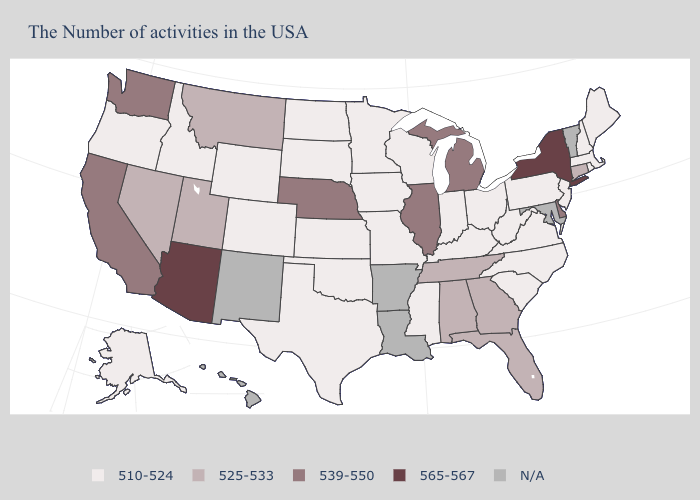What is the value of Louisiana?
Write a very short answer. N/A. Name the states that have a value in the range 539-550?
Keep it brief. Delaware, Michigan, Illinois, Nebraska, California, Washington. Name the states that have a value in the range 510-524?
Short answer required. Maine, Massachusetts, Rhode Island, New Hampshire, New Jersey, Pennsylvania, Virginia, North Carolina, South Carolina, West Virginia, Ohio, Kentucky, Indiana, Wisconsin, Mississippi, Missouri, Minnesota, Iowa, Kansas, Oklahoma, Texas, South Dakota, North Dakota, Wyoming, Colorado, Idaho, Oregon, Alaska. What is the lowest value in the MidWest?
Short answer required. 510-524. Is the legend a continuous bar?
Write a very short answer. No. How many symbols are there in the legend?
Answer briefly. 5. Does the map have missing data?
Concise answer only. Yes. Name the states that have a value in the range 510-524?
Keep it brief. Maine, Massachusetts, Rhode Island, New Hampshire, New Jersey, Pennsylvania, Virginia, North Carolina, South Carolina, West Virginia, Ohio, Kentucky, Indiana, Wisconsin, Mississippi, Missouri, Minnesota, Iowa, Kansas, Oklahoma, Texas, South Dakota, North Dakota, Wyoming, Colorado, Idaho, Oregon, Alaska. Name the states that have a value in the range 539-550?
Answer briefly. Delaware, Michigan, Illinois, Nebraska, California, Washington. Does Arizona have the highest value in the West?
Quick response, please. Yes. What is the value of Louisiana?
Give a very brief answer. N/A. Among the states that border Pennsylvania , does New York have the highest value?
Give a very brief answer. Yes. Among the states that border New York , which have the highest value?
Be succinct. Connecticut. What is the lowest value in states that border Texas?
Give a very brief answer. 510-524. 